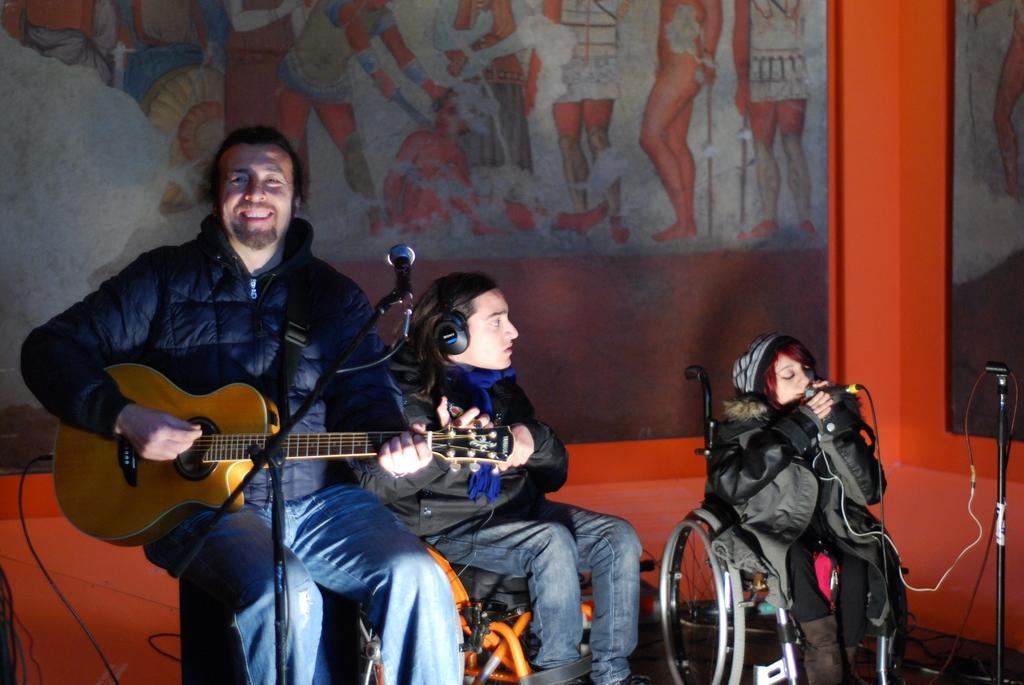Could you give a brief overview of what you see in this image? In this picture we can see three people holding some musical instruments wearing black jackets. 